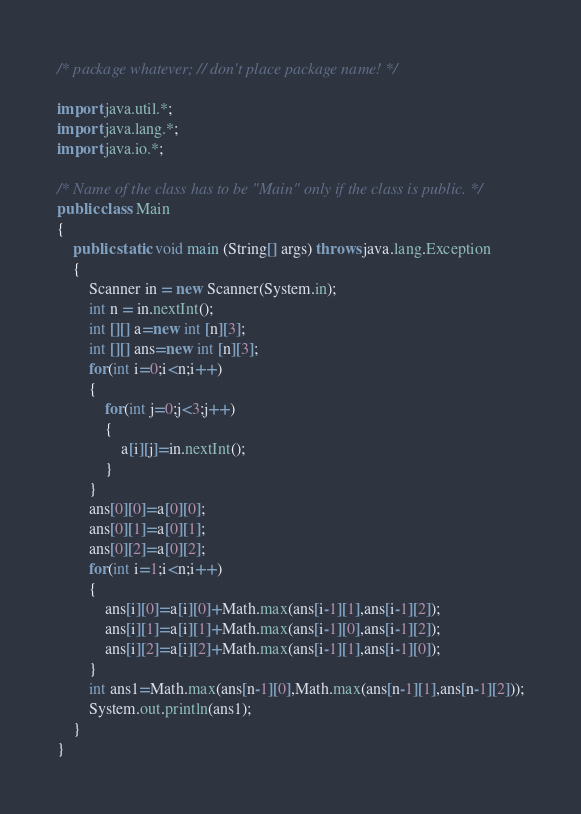<code> <loc_0><loc_0><loc_500><loc_500><_Java_>/* package whatever; // don't place package name! */

import java.util.*;
import java.lang.*;
import java.io.*;

/* Name of the class has to be "Main" only if the class is public. */
public class Main
{
	public static void main (String[] args) throws java.lang.Exception
	{
		Scanner in = new Scanner(System.in);
		int n = in.nextInt();
		int [][] a=new int [n][3];
		int [][] ans=new int [n][3];
		for(int i=0;i<n;i++)
		{
			for(int j=0;j<3;j++)
			{
				a[i][j]=in.nextInt();
			}
		}
		ans[0][0]=a[0][0];
		ans[0][1]=a[0][1];
		ans[0][2]=a[0][2];
		for(int i=1;i<n;i++)
		{
			ans[i][0]=a[i][0]+Math.max(ans[i-1][1],ans[i-1][2]);
			ans[i][1]=a[i][1]+Math.max(ans[i-1][0],ans[i-1][2]);
			ans[i][2]=a[i][2]+Math.max(ans[i-1][1],ans[i-1][0]);
		}
		int ans1=Math.max(ans[n-1][0],Math.max(ans[n-1][1],ans[n-1][2]));
		System.out.println(ans1);
	}
}</code> 